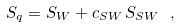Convert formula to latex. <formula><loc_0><loc_0><loc_500><loc_500>S _ { q } = S _ { W } + c _ { S W } \, S _ { S W } \ ,</formula> 